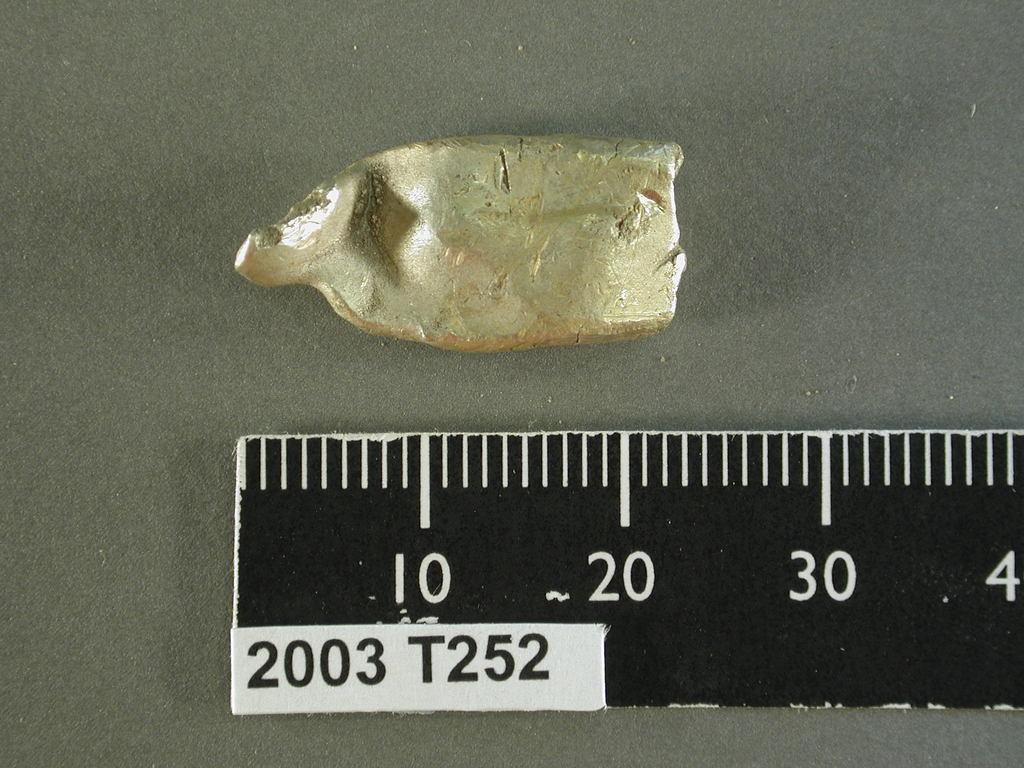<image>
Write a terse but informative summary of the picture. A piece of something being measured against a ruler that says  2003 T252. 